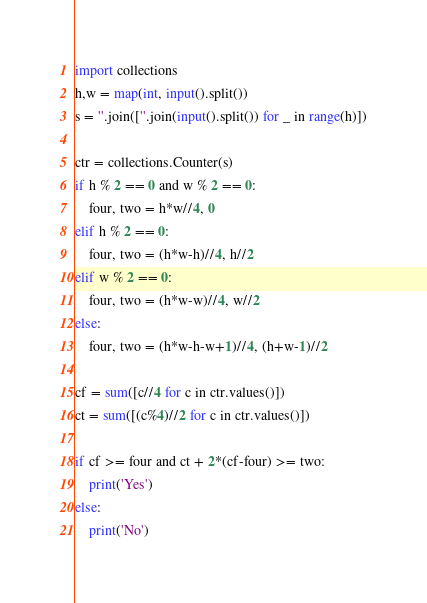Convert code to text. <code><loc_0><loc_0><loc_500><loc_500><_Python_>import collections
h,w = map(int, input().split())
s = ''.join([''.join(input().split()) for _ in range(h)])

ctr = collections.Counter(s)
if h % 2 == 0 and w % 2 == 0:
    four, two = h*w//4, 0
elif h % 2 == 0:
    four, two = (h*w-h)//4, h//2
elif w % 2 == 0:
    four, two = (h*w-w)//4, w//2
else:
    four, two = (h*w-h-w+1)//4, (h+w-1)//2

cf = sum([c//4 for c in ctr.values()])
ct = sum([(c%4)//2 for c in ctr.values()])

if cf >= four and ct + 2*(cf-four) >= two:
    print('Yes')
else:
    print('No')</code> 